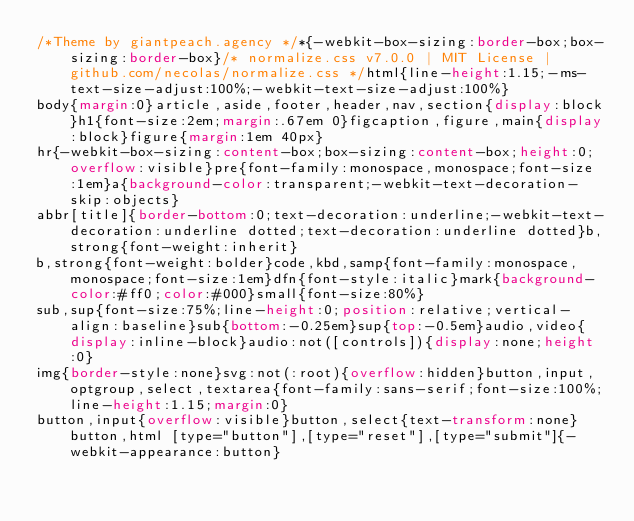<code> <loc_0><loc_0><loc_500><loc_500><_CSS_>/*Theme by giantpeach.agency */*{-webkit-box-sizing:border-box;box-sizing:border-box}/* normalize.css v7.0.0 | MIT License | github.com/necolas/normalize.css */html{line-height:1.15;-ms-text-size-adjust:100%;-webkit-text-size-adjust:100%}
body{margin:0}article,aside,footer,header,nav,section{display:block}h1{font-size:2em;margin:.67em 0}figcaption,figure,main{display:block}figure{margin:1em 40px}
hr{-webkit-box-sizing:content-box;box-sizing:content-box;height:0;overflow:visible}pre{font-family:monospace,monospace;font-size:1em}a{background-color:transparent;-webkit-text-decoration-skip:objects}
abbr[title]{border-bottom:0;text-decoration:underline;-webkit-text-decoration:underline dotted;text-decoration:underline dotted}b,strong{font-weight:inherit}
b,strong{font-weight:bolder}code,kbd,samp{font-family:monospace,monospace;font-size:1em}dfn{font-style:italic}mark{background-color:#ff0;color:#000}small{font-size:80%}
sub,sup{font-size:75%;line-height:0;position:relative;vertical-align:baseline}sub{bottom:-0.25em}sup{top:-0.5em}audio,video{display:inline-block}audio:not([controls]){display:none;height:0}
img{border-style:none}svg:not(:root){overflow:hidden}button,input,optgroup,select,textarea{font-family:sans-serif;font-size:100%;line-height:1.15;margin:0}
button,input{overflow:visible}button,select{text-transform:none}button,html [type="button"],[type="reset"],[type="submit"]{-webkit-appearance:button}</code> 